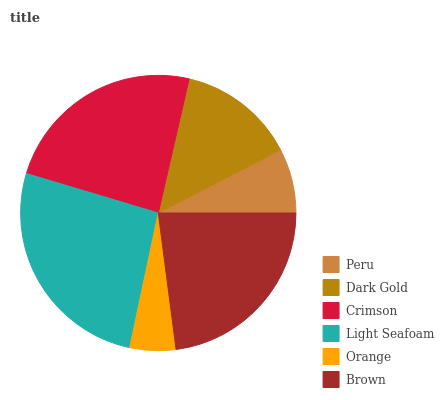Is Orange the minimum?
Answer yes or no. Yes. Is Light Seafoam the maximum?
Answer yes or no. Yes. Is Dark Gold the minimum?
Answer yes or no. No. Is Dark Gold the maximum?
Answer yes or no. No. Is Dark Gold greater than Peru?
Answer yes or no. Yes. Is Peru less than Dark Gold?
Answer yes or no. Yes. Is Peru greater than Dark Gold?
Answer yes or no. No. Is Dark Gold less than Peru?
Answer yes or no. No. Is Brown the high median?
Answer yes or no. Yes. Is Dark Gold the low median?
Answer yes or no. Yes. Is Dark Gold the high median?
Answer yes or no. No. Is Light Seafoam the low median?
Answer yes or no. No. 